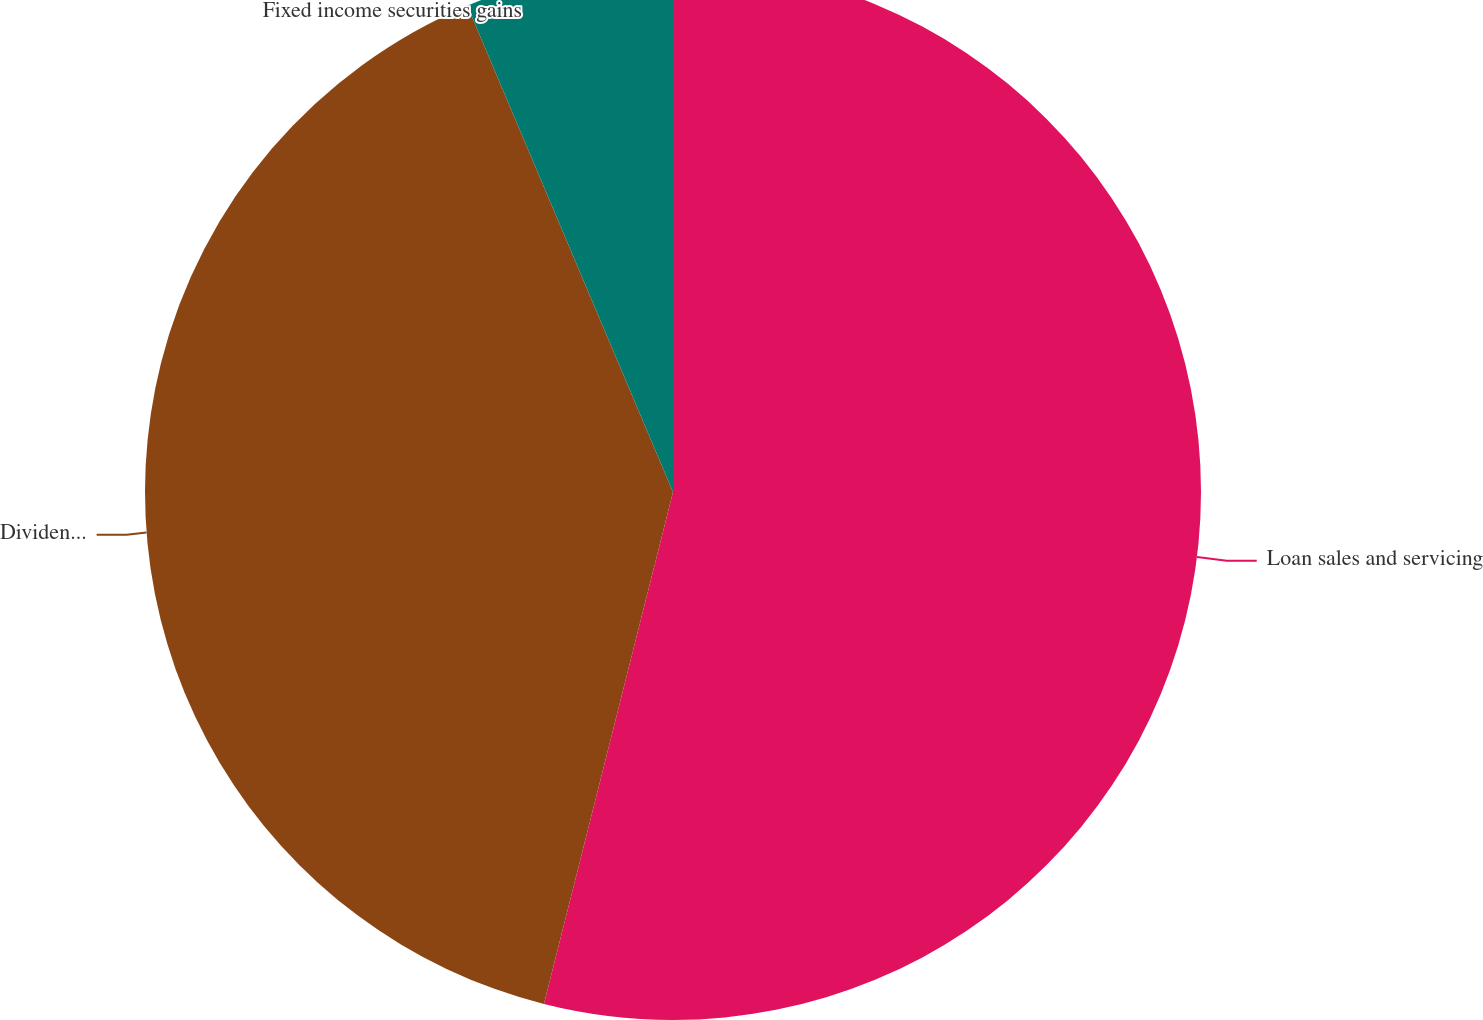Convert chart to OTSL. <chart><loc_0><loc_0><loc_500><loc_500><pie_chart><fcel>Loan sales and servicing<fcel>Dividends and other investment<fcel>Fixed income securities gains<nl><fcel>53.93%<fcel>39.7%<fcel>6.37%<nl></chart> 